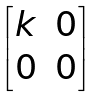Convert formula to latex. <formula><loc_0><loc_0><loc_500><loc_500>\begin{bmatrix} k & 0 \\ 0 & 0 \end{bmatrix}</formula> 